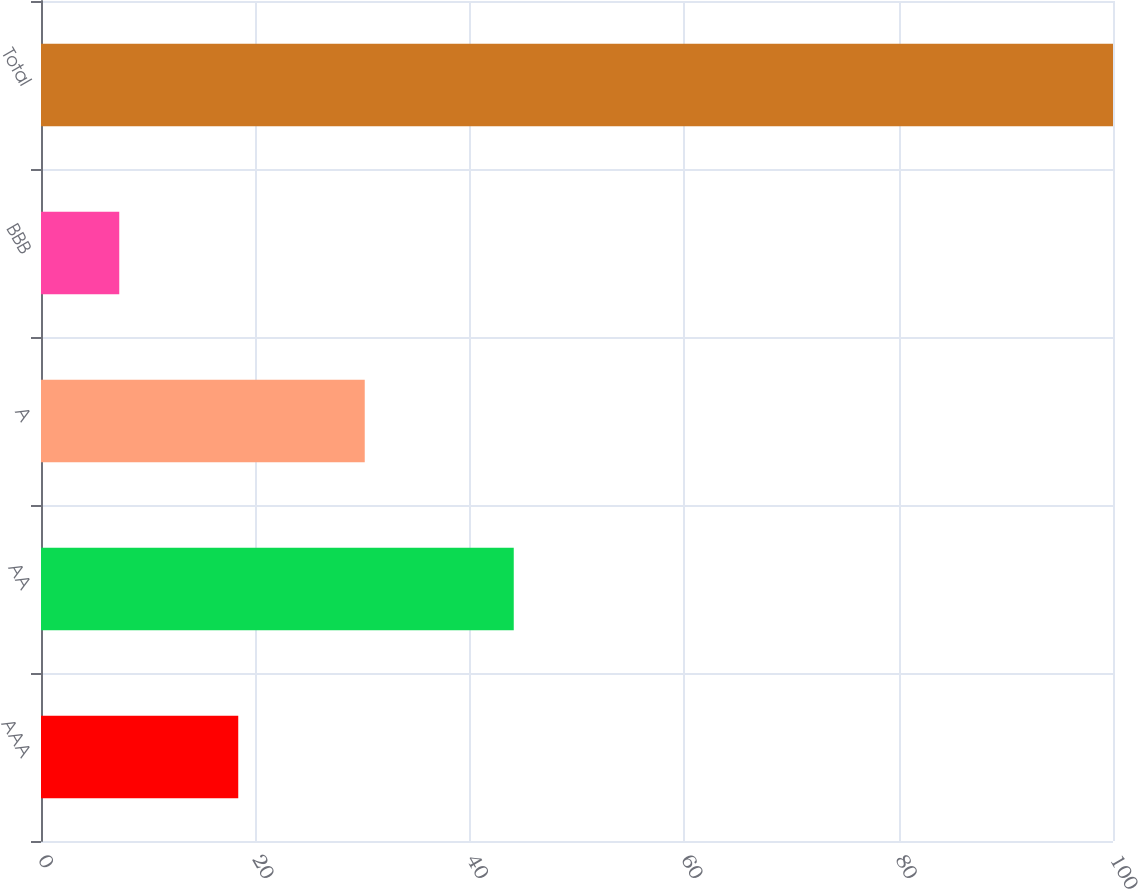<chart> <loc_0><loc_0><loc_500><loc_500><bar_chart><fcel>AAA<fcel>AA<fcel>A<fcel>BBB<fcel>Total<nl><fcel>18.4<fcel>44.1<fcel>30.2<fcel>7.3<fcel>100<nl></chart> 